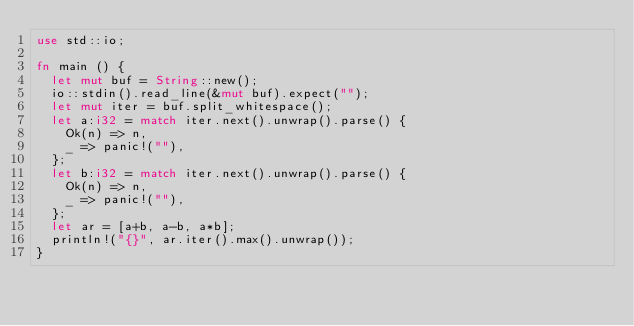Convert code to text. <code><loc_0><loc_0><loc_500><loc_500><_Rust_>use std::io;

fn main () {
	let mut buf = String::new();
	io::stdin().read_line(&mut buf).expect("");
	let mut iter = buf.split_whitespace();
	let a:i32 = match iter.next().unwrap().parse() {
		Ok(n) => n,
		_ => panic!(""),
	};
	let b:i32 = match iter.next().unwrap().parse() {
		Ok(n) => n,
		_ => panic!(""),
	};
	let ar = [a+b, a-b, a*b];
	println!("{}", ar.iter().max().unwrap());
}</code> 